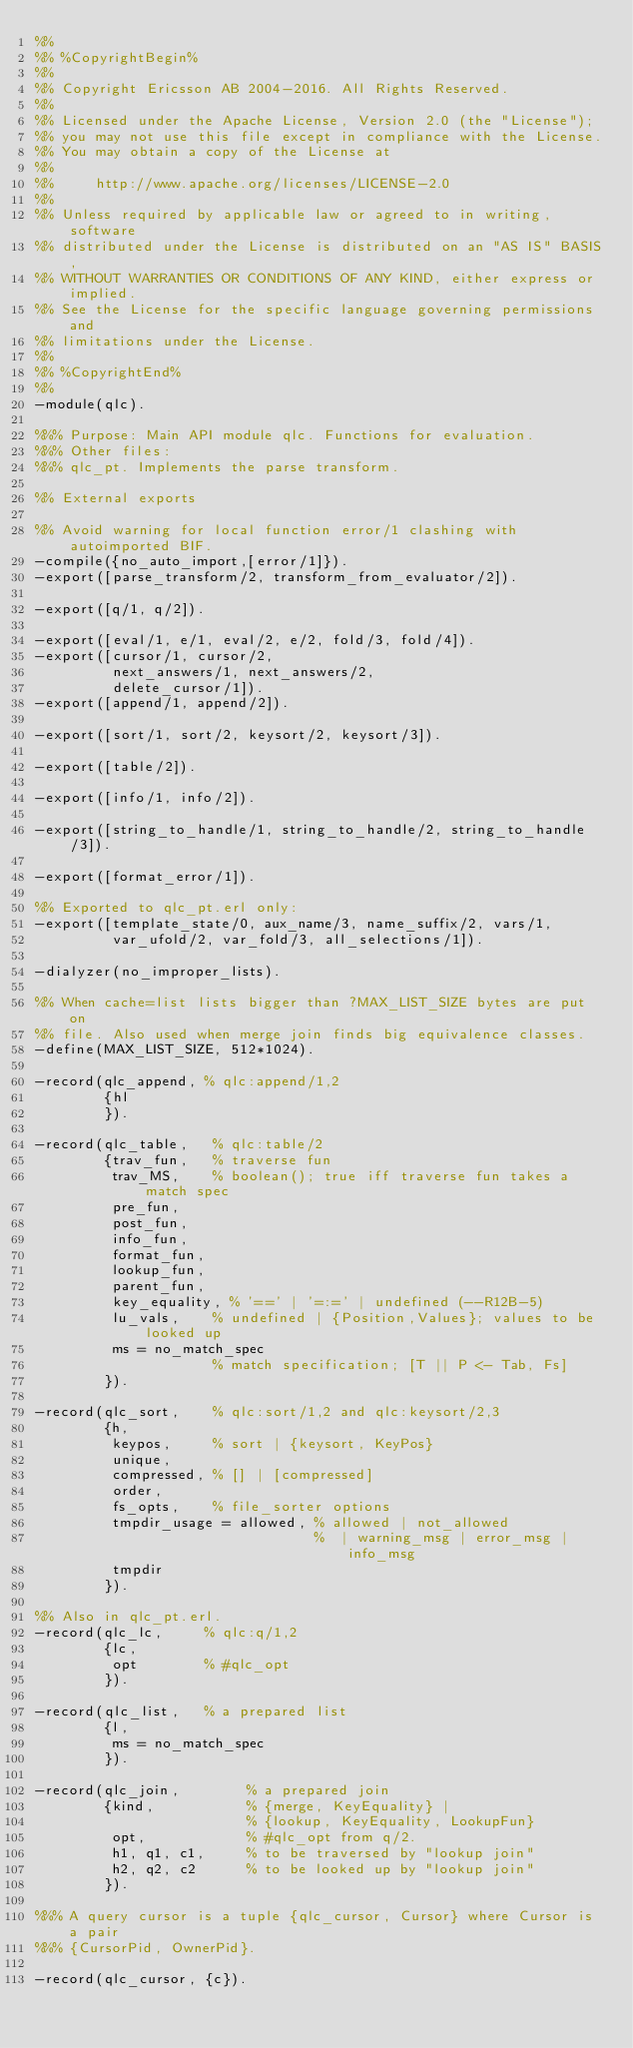<code> <loc_0><loc_0><loc_500><loc_500><_Erlang_>%%
%% %CopyrightBegin%
%%
%% Copyright Ericsson AB 2004-2016. All Rights Reserved.
%%
%% Licensed under the Apache License, Version 2.0 (the "License");
%% you may not use this file except in compliance with the License.
%% You may obtain a copy of the License at
%%
%%     http://www.apache.org/licenses/LICENSE-2.0
%%
%% Unless required by applicable law or agreed to in writing, software
%% distributed under the License is distributed on an "AS IS" BASIS,
%% WITHOUT WARRANTIES OR CONDITIONS OF ANY KIND, either express or implied.
%% See the License for the specific language governing permissions and
%% limitations under the License.
%%
%% %CopyrightEnd%
%%
-module(qlc).

%%% Purpose: Main API module qlc. Functions for evaluation.
%%% Other files:
%%% qlc_pt. Implements the parse transform.

%% External exports 

%% Avoid warning for local function error/1 clashing with autoimported BIF.
-compile({no_auto_import,[error/1]}).
-export([parse_transform/2, transform_from_evaluator/2]).

-export([q/1, q/2]).

-export([eval/1, e/1, eval/2, e/2, fold/3, fold/4]).
-export([cursor/1, cursor/2, 
         next_answers/1, next_answers/2, 
         delete_cursor/1]).
-export([append/1, append/2]).

-export([sort/1, sort/2, keysort/2, keysort/3]).

-export([table/2]).

-export([info/1, info/2]).

-export([string_to_handle/1, string_to_handle/2, string_to_handle/3]).

-export([format_error/1]).

%% Exported to qlc_pt.erl only:
-export([template_state/0, aux_name/3, name_suffix/2, vars/1,
         var_ufold/2, var_fold/3, all_selections/1]).

-dialyzer(no_improper_lists).

%% When cache=list lists bigger than ?MAX_LIST_SIZE bytes are put on
%% file. Also used when merge join finds big equivalence classes.
-define(MAX_LIST_SIZE, 512*1024).

-record(qlc_append, % qlc:append/1,2
        {hl
        }).

-record(qlc_table,   % qlc:table/2
        {trav_fun,   % traverse fun
         trav_MS,    % boolean(); true iff traverse fun takes a match spec
         pre_fun,
         post_fun,
         info_fun,
         format_fun,
         lookup_fun,
         parent_fun,
         key_equality, % '==' | '=:=' | undefined (--R12B-5)
         lu_vals,    % undefined | {Position,Values}; values to be looked up
         ms = no_match_spec
                     % match specification; [T || P <- Tab, Fs]
        }).

-record(qlc_sort,    % qlc:sort/1,2 and qlc:keysort/2,3
        {h,
         keypos,     % sort | {keysort, KeyPos}
         unique,
         compressed, % [] | [compressed]
         order,
         fs_opts,    % file_sorter options
         tmpdir_usage = allowed, % allowed | not_allowed 
                                 %  | warning_msg | error_msg | info_msg
         tmpdir
        }).

%% Also in qlc_pt.erl.
-record(qlc_lc,     % qlc:q/1,2
        {lc,
         opt        % #qlc_opt
        }).

-record(qlc_list,   % a prepared list
        {l,
         ms = no_match_spec
        }).

-record(qlc_join,        % a prepared join
        {kind,           % {merge, KeyEquality} |
                         % {lookup, KeyEquality, LookupFun}
         opt,            % #qlc_opt from q/2.
         h1, q1, c1,     % to be traversed by "lookup join"
         h2, q2, c2      % to be looked up by "lookup join"
        }).

%%% A query cursor is a tuple {qlc_cursor, Cursor} where Cursor is a pair
%%% {CursorPid, OwnerPid}.

-record(qlc_cursor, {c}).
</code> 